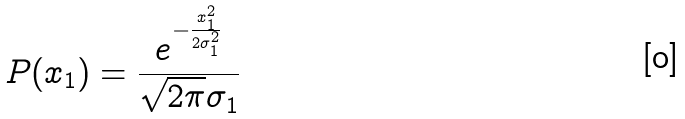Convert formula to latex. <formula><loc_0><loc_0><loc_500><loc_500>P ( x _ { 1 } ) = \frac { e ^ { - \frac { x _ { 1 } ^ { 2 } } { 2 \sigma _ { 1 } ^ { 2 } } } } { \sqrt { 2 \pi } \sigma _ { 1 } }</formula> 